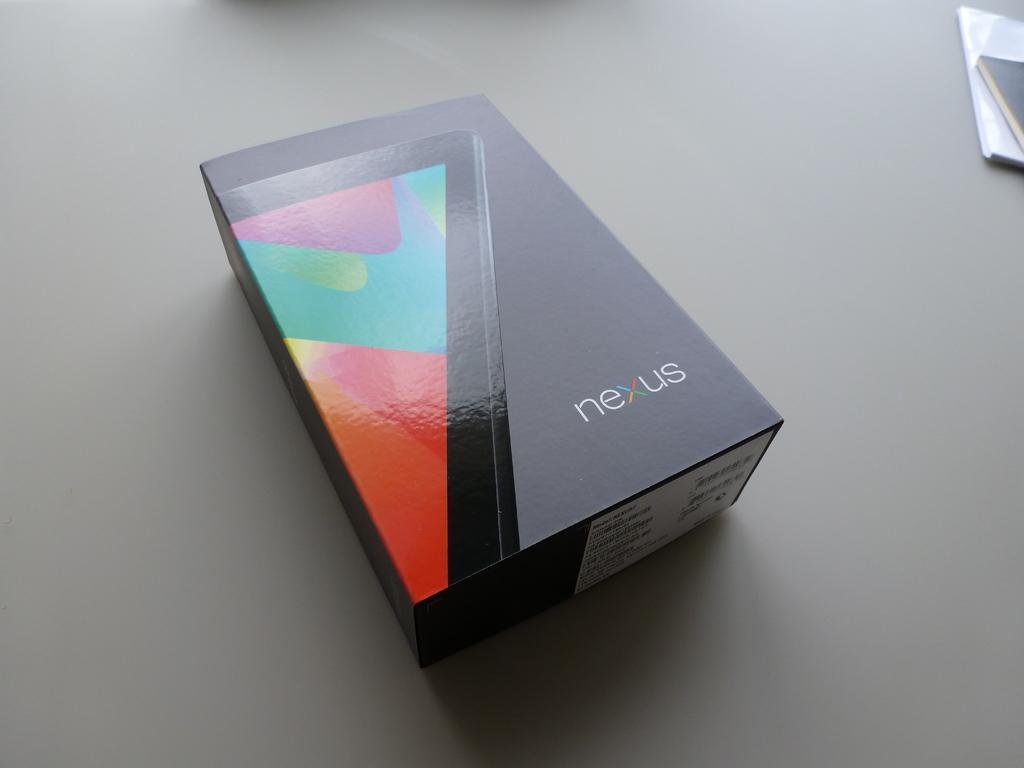In one or two sentences, can you explain what this image depicts? In this image we can see a box and books on the table. 